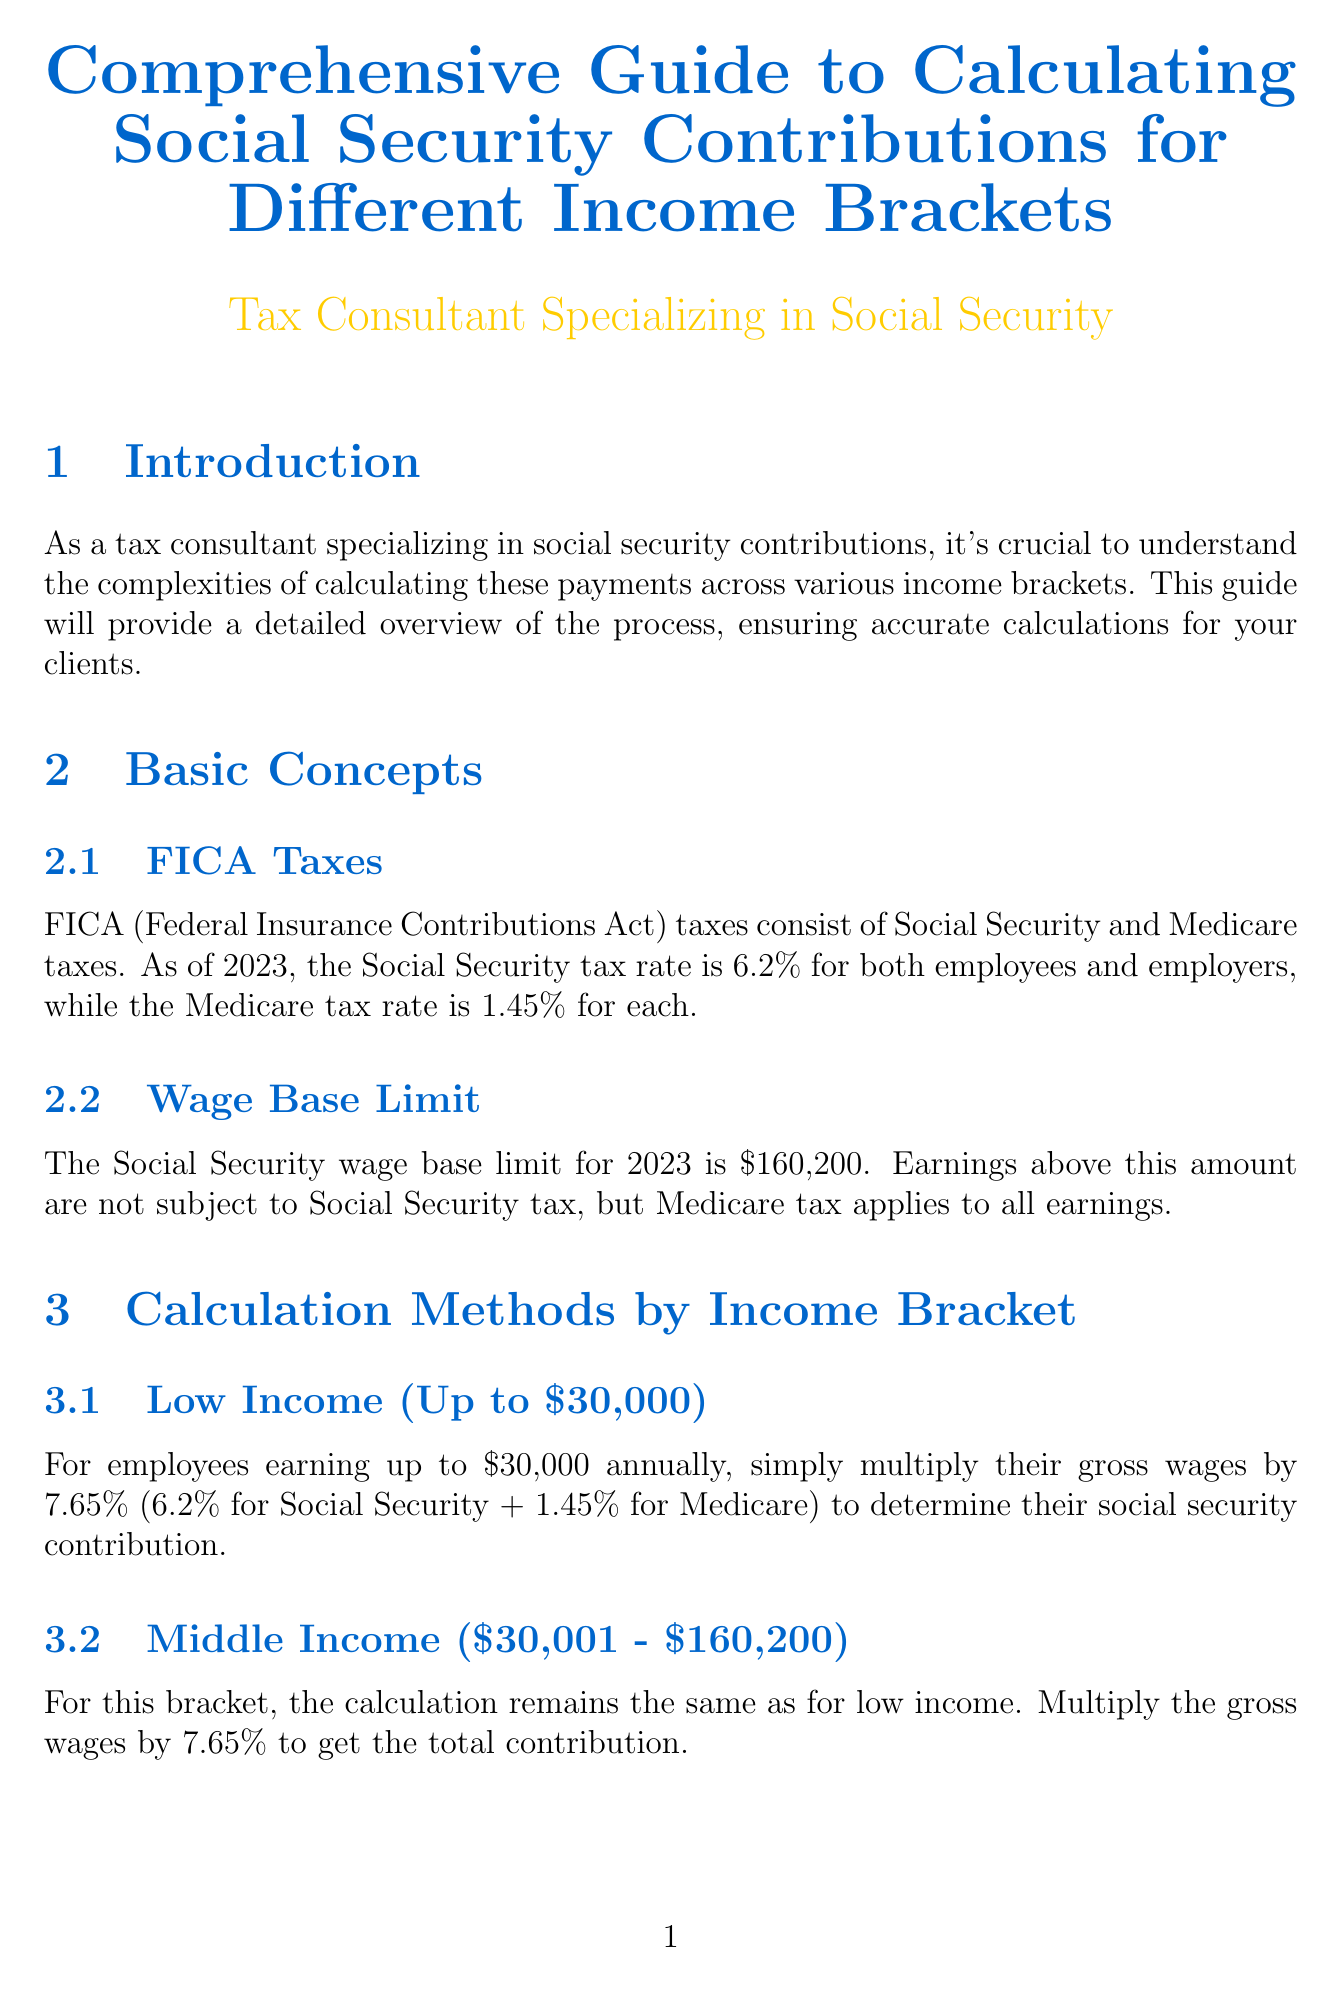what is the Social Security tax rate for 2023? The Social Security tax rate is specified in the document for 2023, indicating it is 6.2%.
Answer: 6.2% what is the Medicare tax rate for employees? The Medicare tax rate for employees is included in the basic concepts section of the document, stating it is 1.45%.
Answer: 1.45% what is the wage base limit for Social Security in 2023? The document mentions that the Social Security wage base limit for 2023 is $160,200.
Answer: $160,200 how is the contribution calculated for low-income employees? The section for low income explains that for employees earning up to $30,000, you multiply their gross wages by 7.65%.
Answer: 7.65% what additional Medicare tax applies to high-income filers? The document outlines that an additional 0.9% Medicare tax applies to certain high-income earners, specifically single filers over $200,000.
Answer: 0.9% who should be referred to IRS Publication 15? The document states to refer to IRS Publication 15 for the most up-to-date information on employment tax rates and wage base limits, implying tax consultants or accountants should refer to it.
Answer: Tax consultants which forms must report social security contributions for employees? The compliance section specifies that social security contributions for employees should be reported on Forms W-2.
Answer: Forms W-2 what is the total FICA tax rate for self-employed individuals? According to the self-employment section, self-employed individuals pay a total of 15.3% in FICA taxes.
Answer: 15.3% what is a situation where a client might get a refund of excess taxes? The special cases section indicates that if a client has multiple employers and exceeds the wage base limit, they may be entitled to a refund.
Answer: Multiple employers 